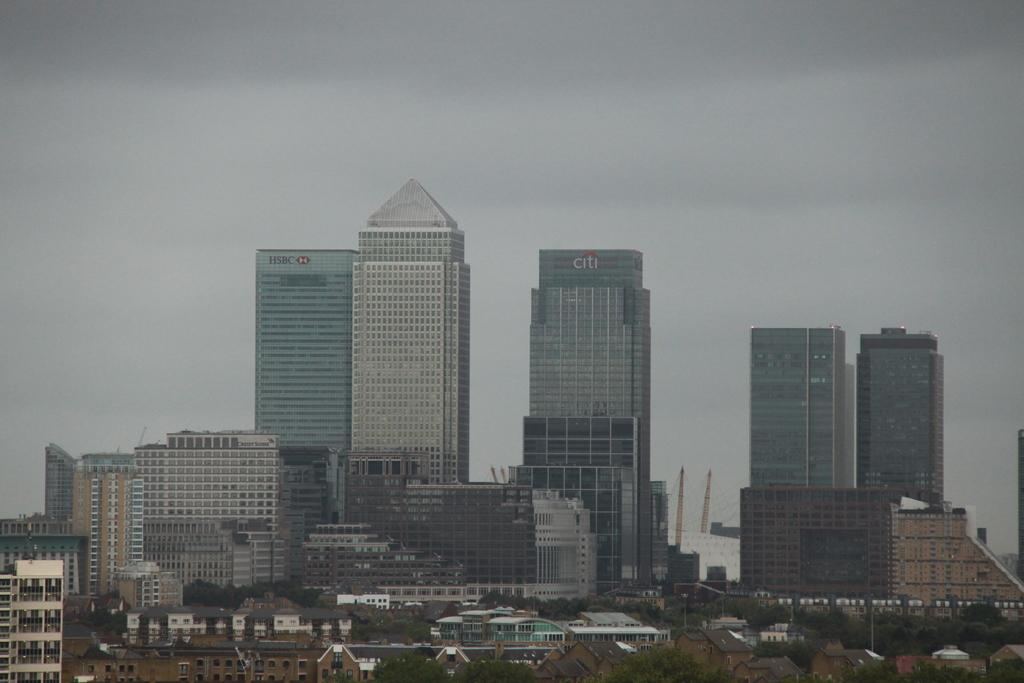What type of structures can be seen in the image? There are many buildings in the image. Are there any other objects or features visible in the image? Yes, there are few poles and trees in the image. What can be seen in the background of the image? In the background of the image, there are trees and towers. What type of cactus can be seen in the image? There is no cactus present in the image. What are the people in the image reading? There are no people or reading material visible in the image. 